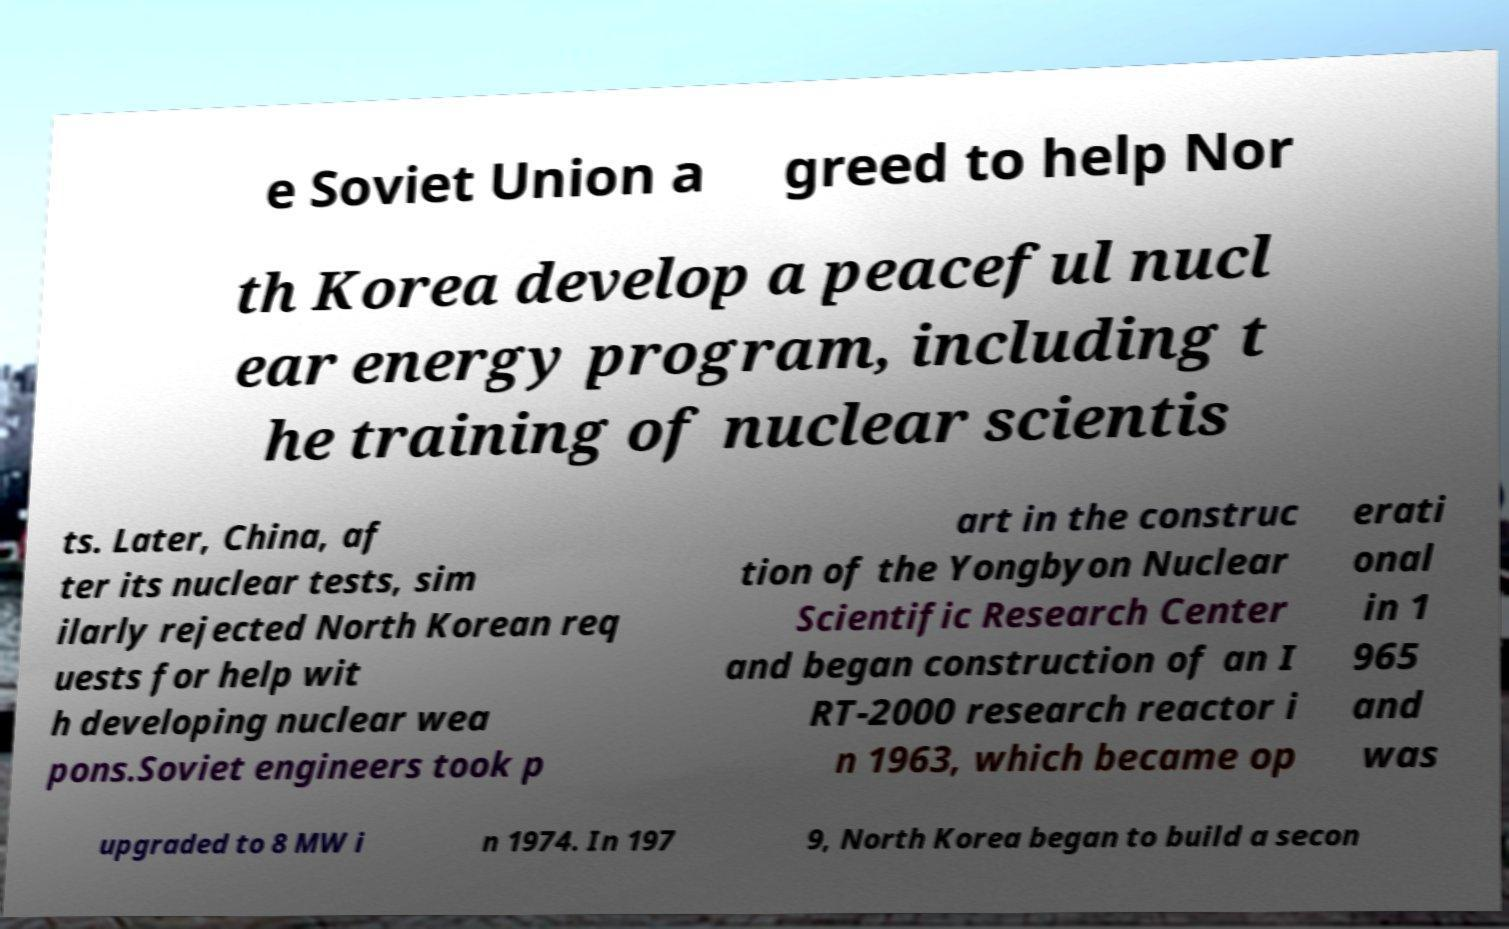Please read and relay the text visible in this image. What does it say? e Soviet Union a greed to help Nor th Korea develop a peaceful nucl ear energy program, including t he training of nuclear scientis ts. Later, China, af ter its nuclear tests, sim ilarly rejected North Korean req uests for help wit h developing nuclear wea pons.Soviet engineers took p art in the construc tion of the Yongbyon Nuclear Scientific Research Center and began construction of an I RT-2000 research reactor i n 1963, which became op erati onal in 1 965 and was upgraded to 8 MW i n 1974. In 197 9, North Korea began to build a secon 